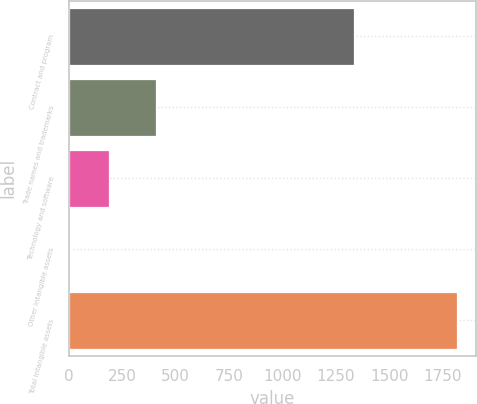Convert chart. <chart><loc_0><loc_0><loc_500><loc_500><bar_chart><fcel>Contract and program<fcel>Trade names and trademarks<fcel>Technology and software<fcel>Other intangible assets<fcel>Total intangible assets<nl><fcel>1333<fcel>407<fcel>188.5<fcel>8<fcel>1813<nl></chart> 